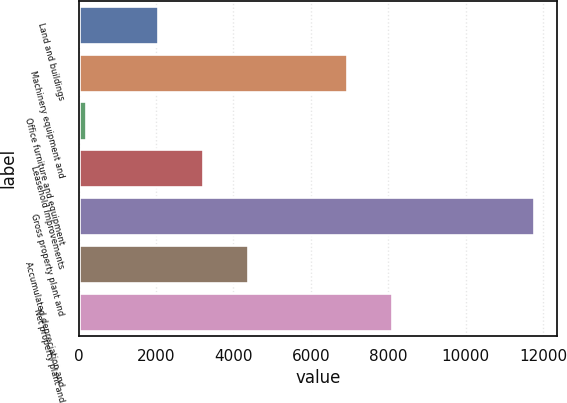Convert chart to OTSL. <chart><loc_0><loc_0><loc_500><loc_500><bar_chart><fcel>Land and buildings<fcel>Machinery equipment and<fcel>Office furniture and equipment<fcel>Leasehold improvements<fcel>Gross property plant and<fcel>Accumulated depreciation and<fcel>Net property plant and<nl><fcel>2059<fcel>6926<fcel>184<fcel>3217.4<fcel>11768<fcel>4375.8<fcel>8084.4<nl></chart> 